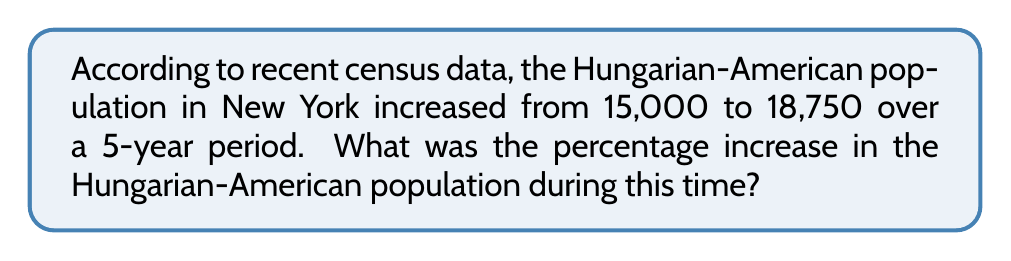Can you solve this math problem? To calculate the percentage increase, we'll follow these steps:

1. Calculate the difference in population:
   $18,750 - 15,000 = 3,750$

2. Divide the increase by the original population:
   $\frac{3,750}{15,000} = 0.25$

3. Convert the decimal to a percentage by multiplying by 100:
   $0.25 \times 100 = 25\%$

The formula for percentage increase is:

$$\text{Percentage Increase} = \frac{\text{Increase}}{\text{Original Value}} \times 100\%$$

Plugging in our values:

$$\text{Percentage Increase} = \frac{18,750 - 15,000}{15,000} \times 100\% = \frac{3,750}{15,000} \times 100\% = 25\%$$

Therefore, the Hungarian-American population in New York increased by 25% over the 5-year period.
Answer: 25% 